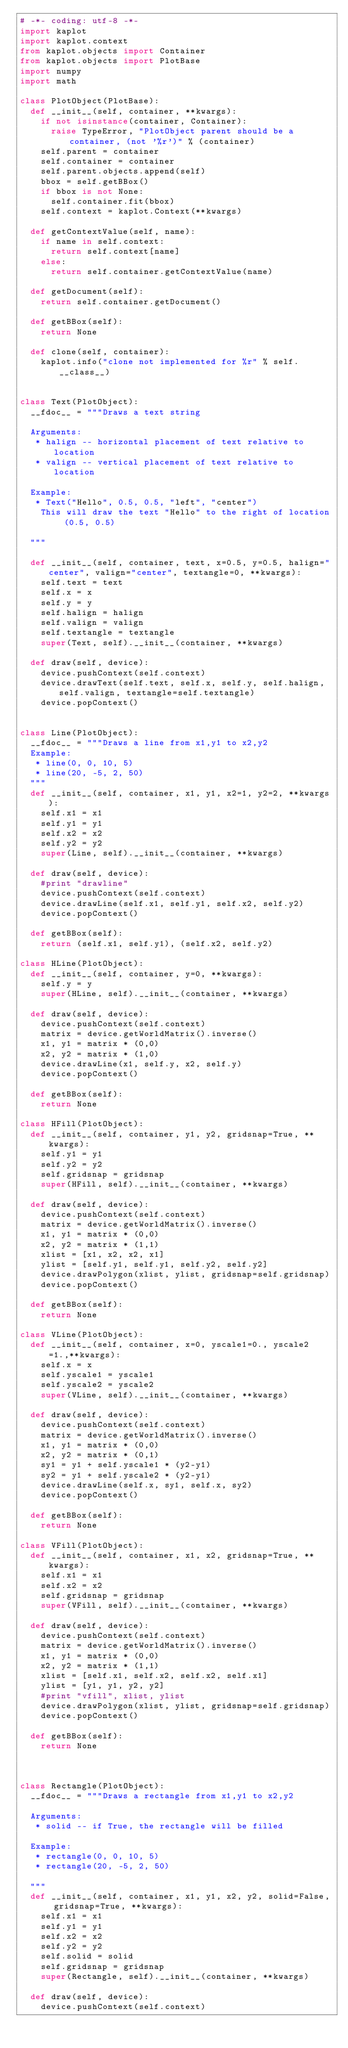<code> <loc_0><loc_0><loc_500><loc_500><_Python_># -*- coding: utf-8 -*-
import kaplot
import kaplot.context
from kaplot.objects import Container
from kaplot.objects import PlotBase
import numpy
import math

class PlotObject(PlotBase):
	def __init__(self, container, **kwargs):
		if not isinstance(container, Container):
			raise TypeError, "PlotObject parent should be a container, (not '%r')" % (container)
		self.parent = container
		self.container = container
		self.parent.objects.append(self)
		bbox = self.getBBox()
		if bbox is not None:
			self.container.fit(bbox)
		self.context = kaplot.Context(**kwargs)
		
	def getContextValue(self, name):
		if name in self.context:
			return self.context[name]
		else:
			return self.container.getContextValue(name)
		
	def getDocument(self):
		return self.container.getDocument()
		
	def getBBox(self):
		return None
		
	def clone(self, container):
		kaplot.info("clone not implemented for %r" % self.__class__)


class Text(PlotObject):
	__fdoc__ = """Draws a text string
	
	Arguments:
	 * halign -- horizontal placement of text relative to location
	 * valign -- vertical placement of text relative to location
	 
	Example:
	 * Text("Hello", 0.5, 0.5, "left", "center")
	 	This will draw the text "Hello" to the right of location (0.5, 0.5)
	
	"""
	
	def __init__(self, container, text, x=0.5, y=0.5, halign="center", valign="center", textangle=0, **kwargs):
		self.text = text
		self.x = x
		self.y = y
		self.halign = halign
		self.valign = valign
		self.textangle = textangle
		super(Text, self).__init__(container, **kwargs)
		
	def draw(self, device):
		device.pushContext(self.context)
		device.drawText(self.text, self.x, self.y, self.halign, self.valign, textangle=self.textangle)
		device.popContext()


class Line(PlotObject):
	__fdoc__ = """Draws a line from x1,y1 to x2,y2
	Example:
	 * line(0, 0, 10, 5)
	 * line(20, -5, 2, 50)
	"""
	def __init__(self, container, x1, y1, x2=1, y2=2, **kwargs):
		self.x1 = x1
		self.y1 = y1
		self.x2 = x2
		self.y2 = y2
		super(Line, self).__init__(container, **kwargs)
		
	def draw(self, device):
		#print "drawline"
		device.pushContext(self.context)
		device.drawLine(self.x1, self.y1, self.x2, self.y2)
		device.popContext()

	def getBBox(self):
		return (self.x1, self.y1), (self.x2, self.y2)

class HLine(PlotObject):
	def __init__(self, container, y=0, **kwargs):
		self.y = y
		super(HLine, self).__init__(container, **kwargs)
		
	def draw(self, device):
		device.pushContext(self.context)
		matrix = device.getWorldMatrix().inverse()
		x1, y1 = matrix * (0,0)
		x2, y2 = matrix * (1,0)
		device.drawLine(x1, self.y, x2, self.y)
		device.popContext()
	
	def getBBox(self):
		return None
				
class HFill(PlotObject):
	def __init__(self, container, y1, y2, gridsnap=True, **kwargs):
		self.y1 = y1
		self.y2 = y2
		self.gridsnap = gridsnap
		super(HFill, self).__init__(container, **kwargs)
		
	def draw(self, device):
		device.pushContext(self.context)
		matrix = device.getWorldMatrix().inverse()
		x1, y1 = matrix * (0,0)
		x2, y2 = matrix * (1,1)
		xlist = [x1, x2, x2, x1]
		ylist = [self.y1, self.y1, self.y2, self.y2]
		device.drawPolygon(xlist, ylist, gridsnap=self.gridsnap)
		device.popContext()
	
	def getBBox(self):
		return None
				
class VLine(PlotObject):
	def __init__(self, container, x=0, yscale1=0., yscale2=1.,**kwargs):
		self.x = x
		self.yscale1 = yscale1
		self.yscale2 = yscale2
		super(VLine, self).__init__(container, **kwargs)
		
	def draw(self, device):
		device.pushContext(self.context)
		matrix = device.getWorldMatrix().inverse()
		x1, y1 = matrix * (0,0)
		x2, y2 = matrix * (0,1)
		sy1 = y1 + self.yscale1 * (y2-y1)
		sy2 = y1 + self.yscale2 * (y2-y1) 
		device.drawLine(self.x, sy1, self.x, sy2)
		device.popContext()
	
	def getBBox(self):
		return None
	
class VFill(PlotObject):
	def __init__(self, container, x1, x2, gridsnap=True, **kwargs):
		self.x1 = x1
		self.x2 = x2
		self.gridsnap = gridsnap
		super(VFill, self).__init__(container, **kwargs)
		
	def draw(self, device):
		device.pushContext(self.context)
		matrix = device.getWorldMatrix().inverse()
		x1, y1 = matrix * (0,0)
		x2, y2 = matrix * (1,1)
		xlist = [self.x1, self.x2, self.x2, self.x1]
		ylist = [y1, y1, y2, y2]
		#print "vfill", xlist, ylist
		device.drawPolygon(xlist, ylist, gridsnap=self.gridsnap)
		device.popContext()
	
	def getBBox(self):
		return None
				
	
				
class Rectangle(PlotObject):
	__fdoc__ = """Draws a rectangle from x1,y1 to x2,y2
	
	Arguments:
	 * solid -- if True, the rectangle will be filled

	Example:
	 * rectangle(0, 0, 10, 5)
	 * rectangle(20, -5, 2, 50)

	"""
	def __init__(self, container, x1, y1, x2, y2, solid=False, gridsnap=True, **kwargs):
		self.x1 = x1
		self.y1 = y1
		self.x2 = x2
		self.y2 = y2
		self.solid = solid
		self.gridsnap = gridsnap
		super(Rectangle, self).__init__(container, **kwargs)
		
	def draw(self, device):
		device.pushContext(self.context)</code> 